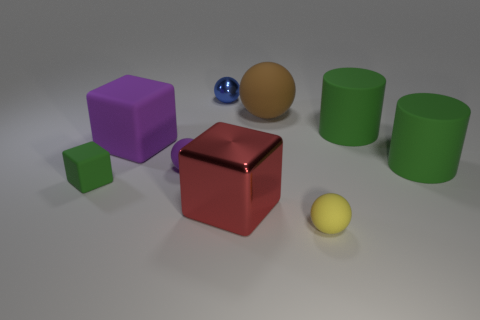Add 1 green matte cubes. How many objects exist? 10 Subtract all cubes. How many objects are left? 6 Add 8 large red matte spheres. How many large red matte spheres exist? 8 Subtract 0 gray cubes. How many objects are left? 9 Subtract all large gray metallic things. Subtract all big brown objects. How many objects are left? 8 Add 7 green blocks. How many green blocks are left? 8 